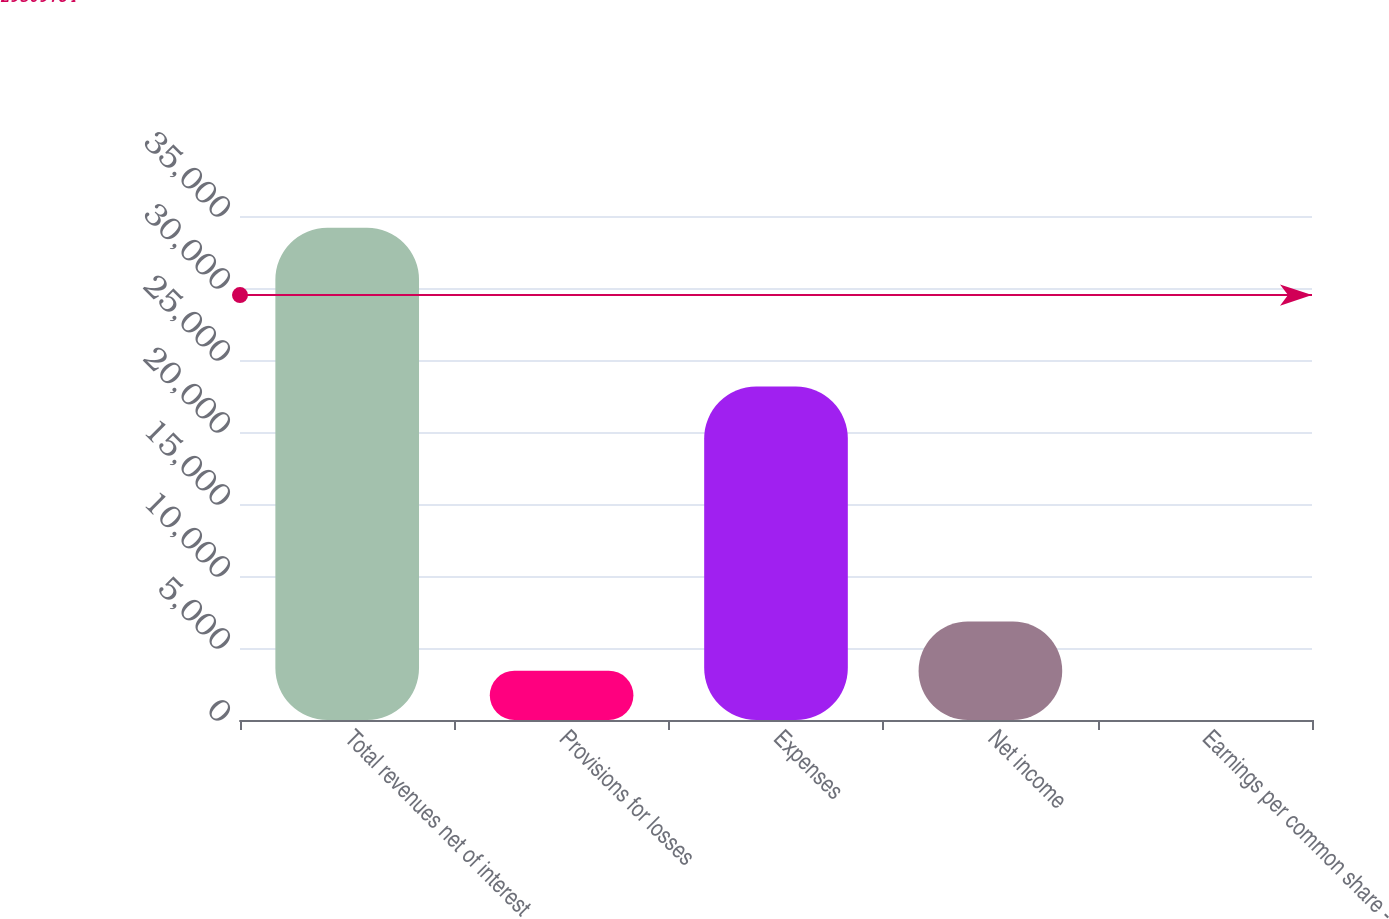Convert chart. <chart><loc_0><loc_0><loc_500><loc_500><bar_chart><fcel>Total revenues net of interest<fcel>Provisions for losses<fcel>Expenses<fcel>Net income<fcel>Earnings per common share -<nl><fcel>34188<fcel>3423.8<fcel>23153<fcel>6842.04<fcel>5.56<nl></chart> 